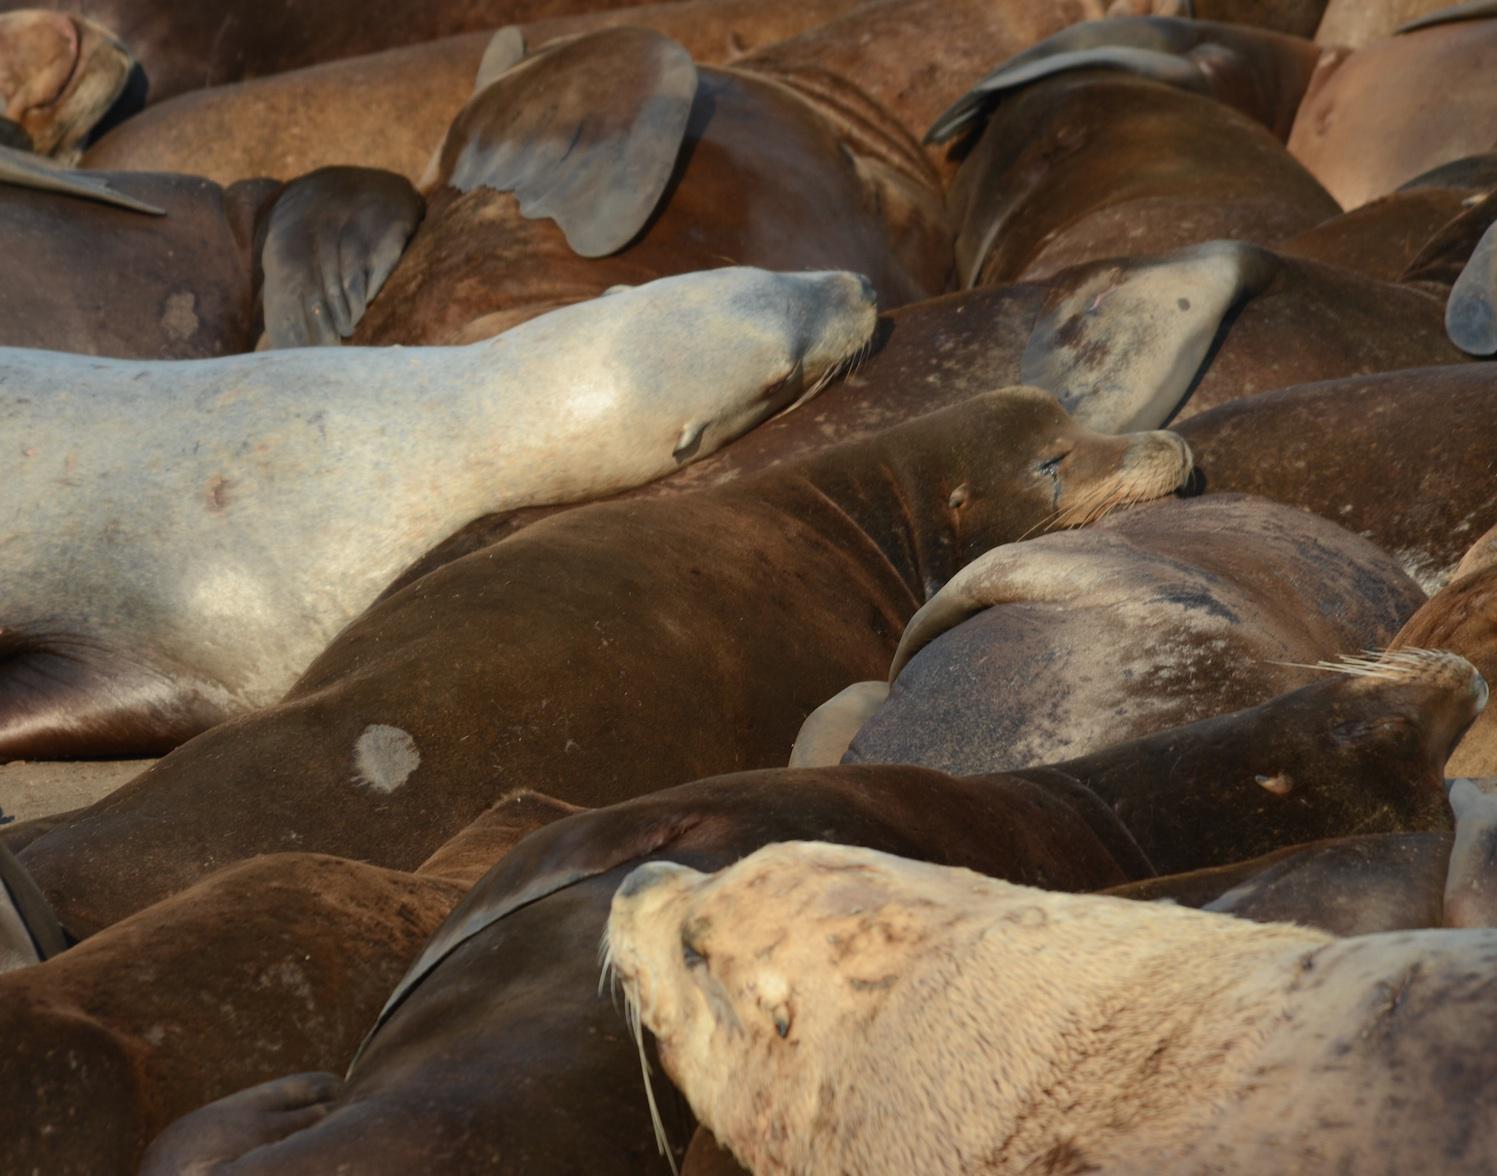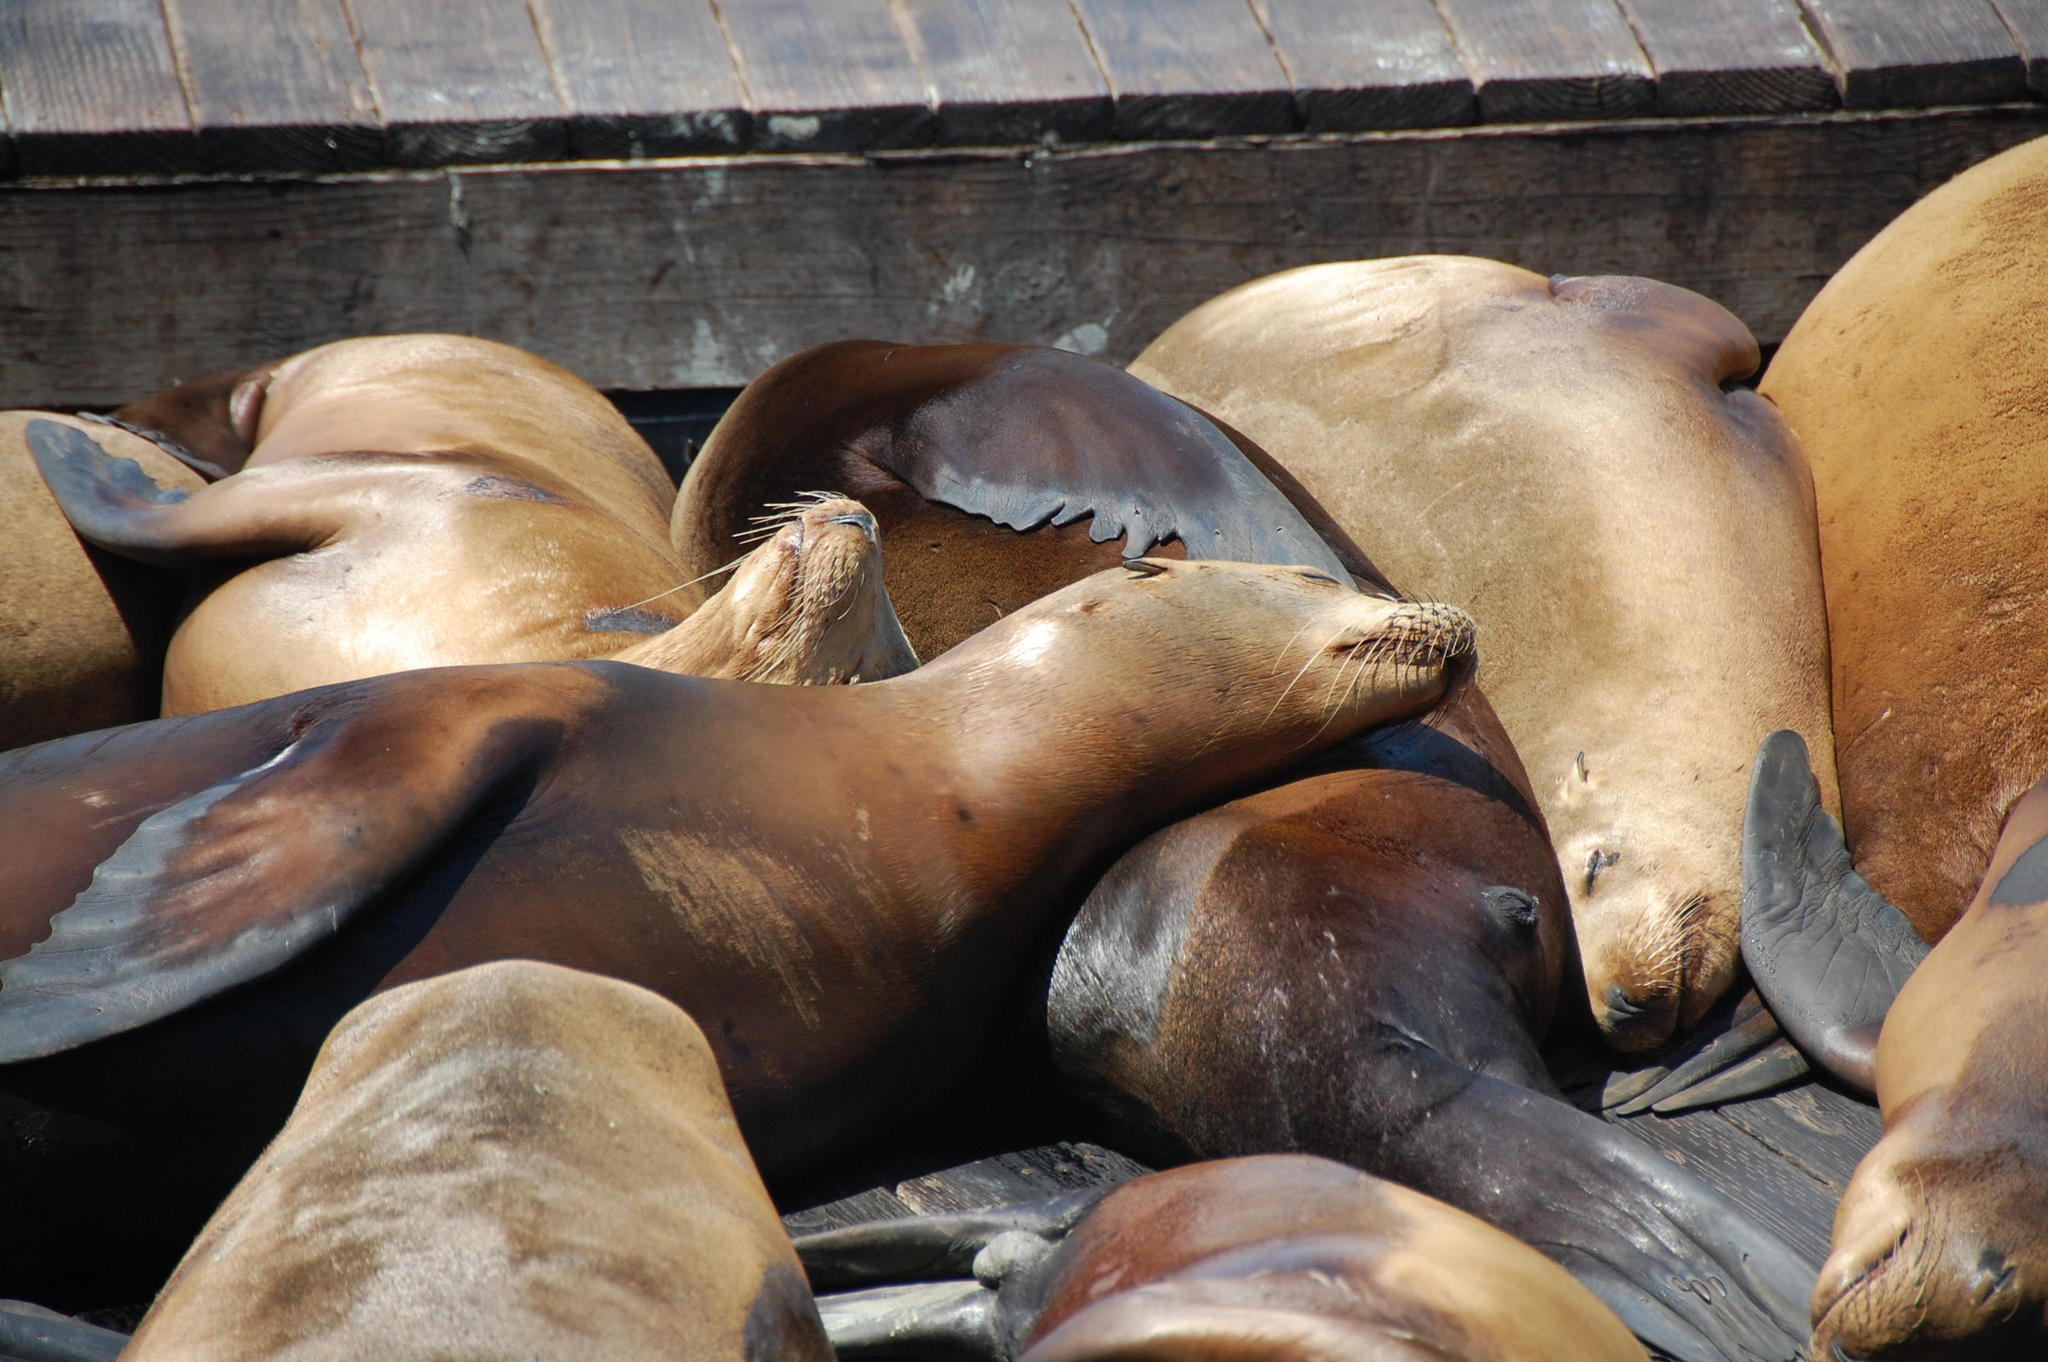The first image is the image on the left, the second image is the image on the right. Examine the images to the left and right. Is the description "The right image contains no more than four seals." accurate? Answer yes or no. No. The first image is the image on the left, the second image is the image on the right. For the images shown, is this caption "Exactly four seal heads are visible in one of the images." true? Answer yes or no. No. 